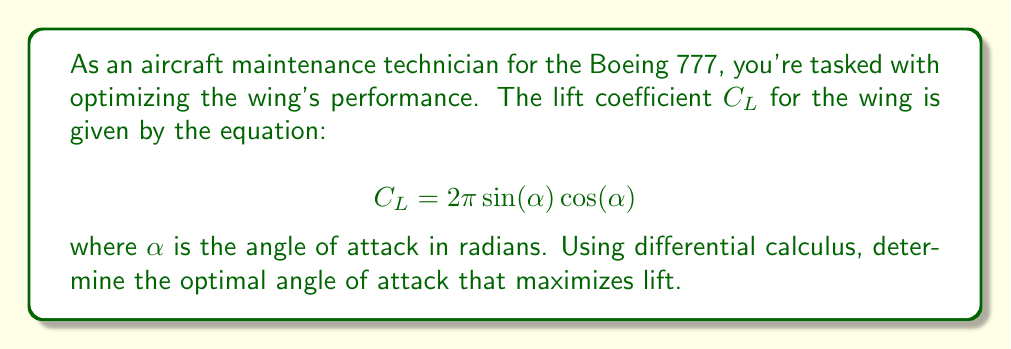Teach me how to tackle this problem. To find the optimal angle of attack for maximum lift, we need to find the maximum value of the lift coefficient $C_L$. This can be done by finding the critical points of the function and determining which one yields the maximum value.

Step 1: Take the derivative of $C_L$ with respect to $\alpha$.
$$\frac{dC_L}{d\alpha} = 2\pi[\cos(\alpha)\cos(\alpha) - \sin(\alpha)\sin(\alpha)]$$
$$\frac{dC_L}{d\alpha} = 2\pi[\cos^2(\alpha) - \sin^2(\alpha)]$$
$$\frac{dC_L}{d\alpha} = 2\pi\cos(2\alpha)$$

Step 2: Set the derivative equal to zero to find critical points.
$$2\pi\cos(2\alpha) = 0$$
$$\cos(2\alpha) = 0$$

Step 3: Solve for $\alpha$.
$$2\alpha = \frac{\pi}{2} + n\pi, \quad n \in \mathbb{Z}$$
$$\alpha = \frac{\pi}{4} + \frac{n\pi}{2}, \quad n \in \mathbb{Z}$$

Step 4: Consider the principal solution in the range $[0, \pi]$.
$$\alpha = \frac{\pi}{4} \approx 0.7854 \text{ radians}$$

Step 5: Verify this is a maximum by checking the second derivative.
$$\frac{d^2C_L}{d\alpha^2} = -4\pi\sin(2\alpha)$$
At $\alpha = \frac{\pi}{4}$, $\frac{d^2C_L}{d\alpha^2} < 0$, confirming a maximum.

Step 6: Convert to degrees for practical application.
$$\alpha = \frac{\pi}{4} \cdot \frac{180^\circ}{\pi} = 45^\circ$$
Answer: $45^\circ$ or $\frac{\pi}{4}$ radians 